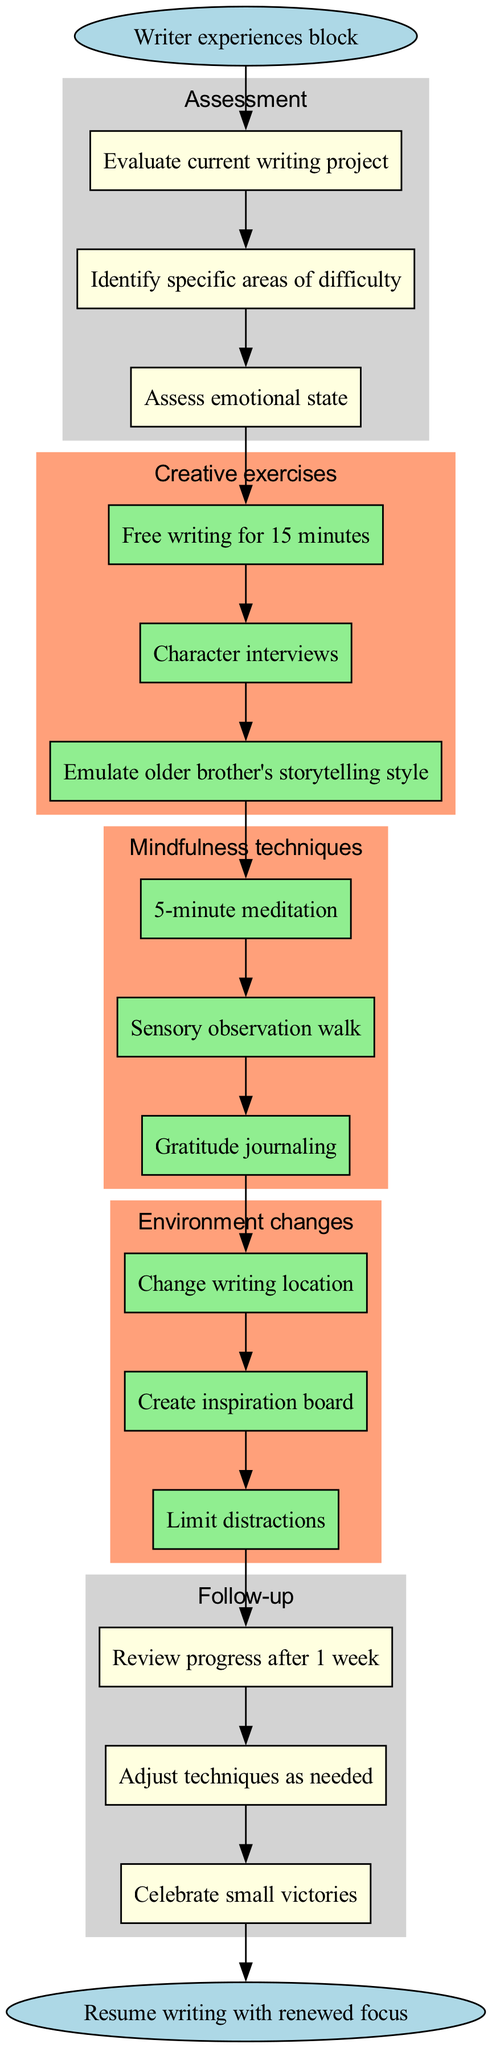What is the starting point of the clinical pathway? The starting point of the clinical pathway is the node labeled "Writer experiences block." This is the first node that initiates the flow of the diagram.
Answer: Writer experiences block How many assessment activities are listed? There are three assessment activities in the diagram, represented by boxes under the "Assessment" cluster. They include evaluating the writing project, identifying areas of difficulty, and assessing emotional state.
Answer: 3 What is the first mindfulness technique mentioned? The first mindfulness technique listed in the diagram is "5-minute meditation." This is the first method under the Mindfulness techniques intervention.
Answer: 5-minute meditation Which intervention follows the assessment phase? The intervention that follows the assessment phase is "Creative exercises," as seen in the flow of the diagram after the last assessment activity.
Answer: Creative exercises How many follow-up steps are outlined in the pathway? There are three follow-up steps outlined in the diagram. These steps focus on reviewing progress, adjusting techniques, and celebrating victories.
Answer: 3 How does "Gratitude journaling" relate to the diagram? "Gratitude journaling" is a part of the mindfulness techniques intervention. It is one of the methods that the pathway suggests for managing writer's block, highlighting the focus on mindfulness.
Answer: Mindfulness techniques What action can writers take to change their environment according to the diagram? Writers can "Change writing location" as one of the actions to modify their environment, as indicated in the "Environment changes" intervention cluster.
Answer: Change writing location Which node leads to the end of the clinical pathway? The node that leads to the end of the clinical pathway is the one labeled "Resume writing with renewed focus." This is the final node after the follow-up activities.
Answer: Resume writing with renewed focus What are writers encouraged to celebrate in the follow-up phase? Writers are encouraged to celebrate "small victories" during the follow-up phase, indicating a focus on positive reinforcement in the process of overcoming writer's block.
Answer: Small victories 